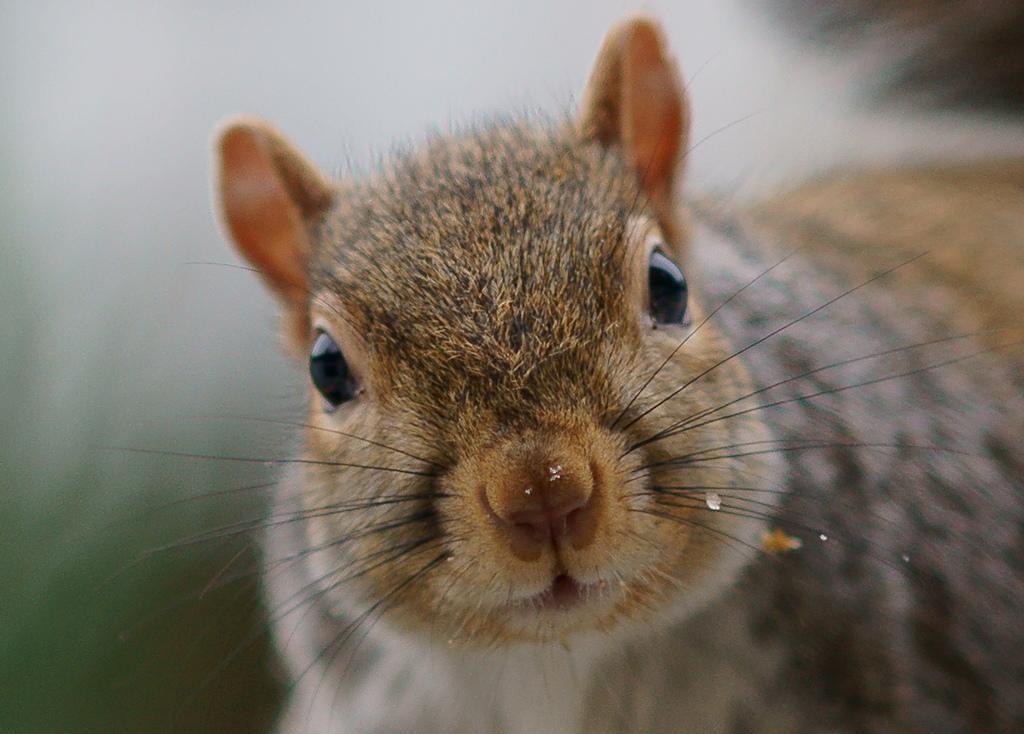Could you give a brief overview of what you see in this image? In this picture we can see an animal and blurry background. 